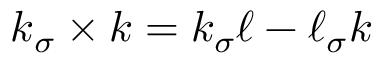Convert formula to latex. <formula><loc_0><loc_0><loc_500><loc_500>k _ { \sigma } \times k = k _ { \sigma } \ell - \ell _ { \sigma } k</formula> 